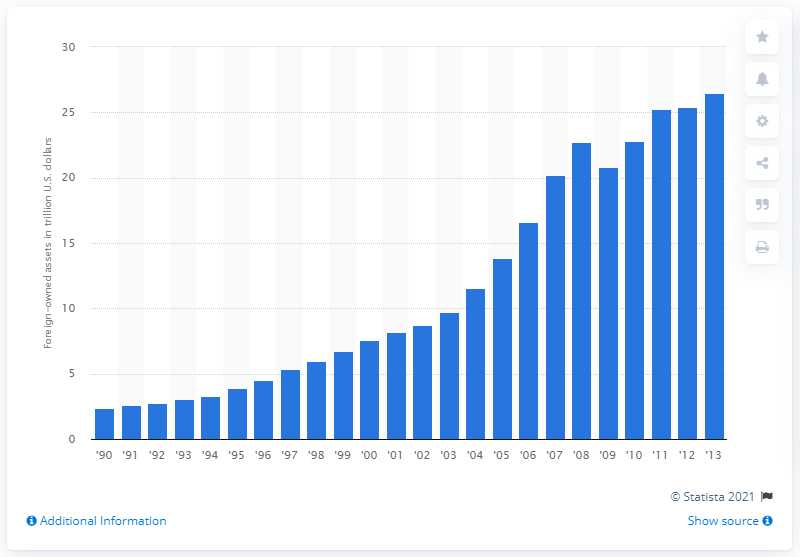Indicate a few pertinent items in this graphic. In 2012, the value of foreign-owned assets in the United States was approximately 25.42. 